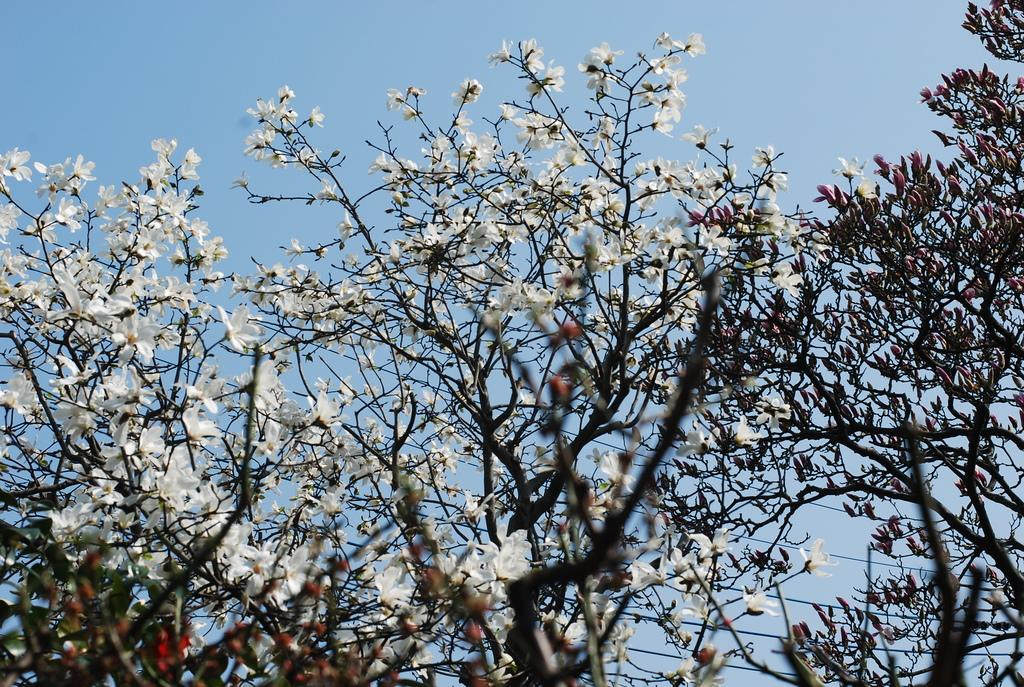What type of vegetation can be seen in the image? There are trees and flowers in the image. What is visible in the background of the image? The sky is visible behind the trees. What type of art is being protested by the boy in the image? There is no boy or protest present in the image; it features trees, flowers, and the sky. 